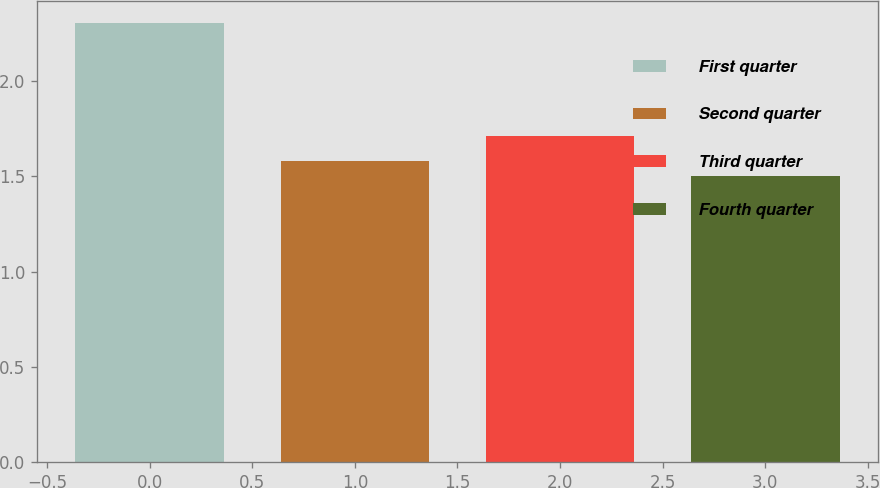Convert chart. <chart><loc_0><loc_0><loc_500><loc_500><bar_chart><fcel>First quarter<fcel>Second quarter<fcel>Third quarter<fcel>Fourth quarter<nl><fcel>2.3<fcel>1.58<fcel>1.71<fcel>1.5<nl></chart> 